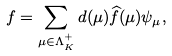Convert formula to latex. <formula><loc_0><loc_0><loc_500><loc_500>f = \sum _ { \mu \in \Lambda _ { K } ^ { + } } d ( \mu ) \widehat { f } ( \mu ) \psi _ { \mu } ,</formula> 